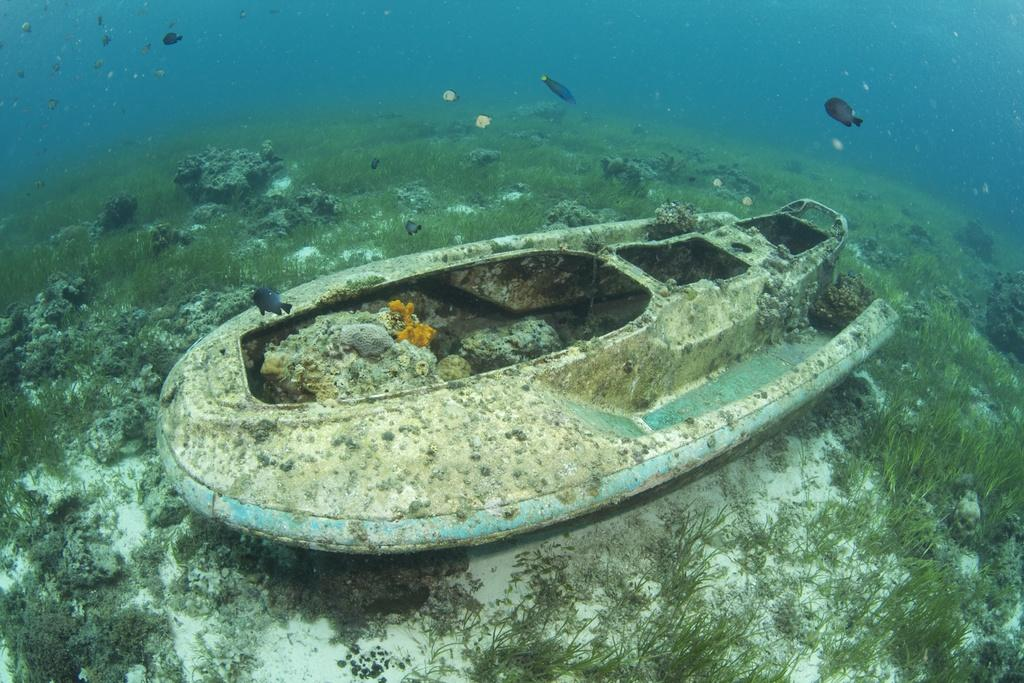What type of animals can be seen in the water in the image? There are fishes in the water in the image. What type of vegetation is visible in the image? There is grass and plants visible in the image. What type of watercraft is present in the image? There is a boat in the image. What action is the woman performing in the image? There is no woman present in the image. 